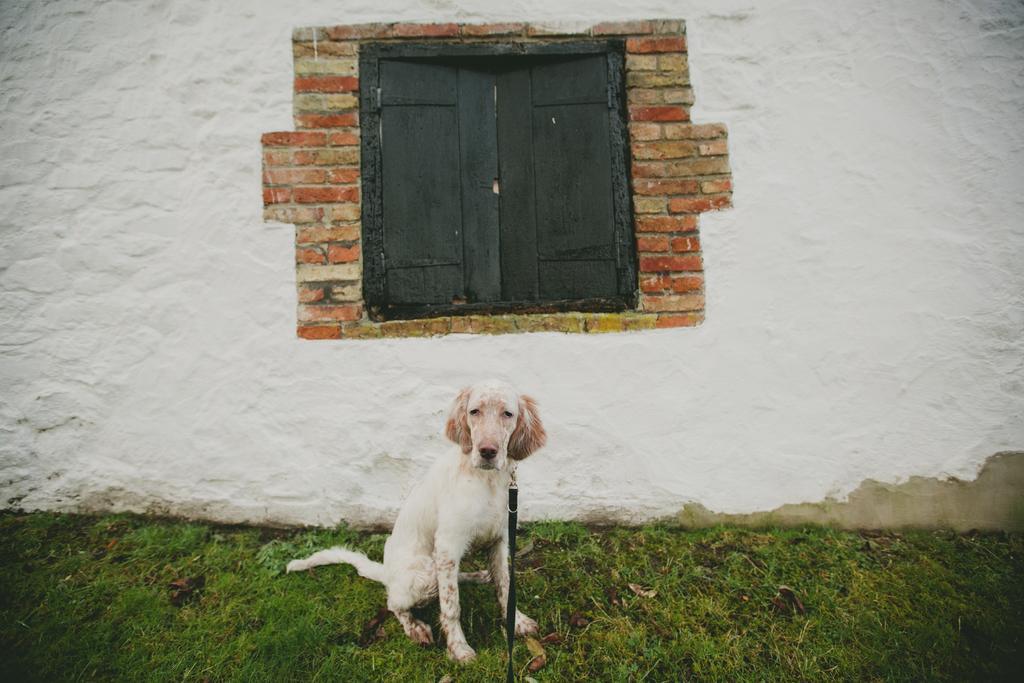Please provide a concise description of this image. In this image we can see a dog with a belt. On the ground there is grass. In the back there is a wall with windows. 